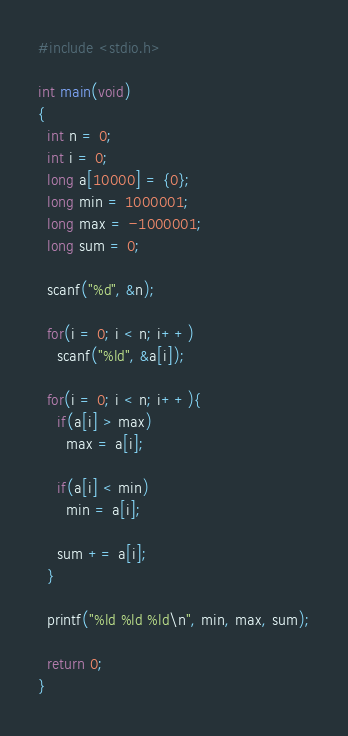Convert code to text. <code><loc_0><loc_0><loc_500><loc_500><_C_>#include <stdio.h>

int main(void)
{
  int n = 0;
  int i = 0;
  long a[10000] = {0};
  long min = 1000001;
  long max = -1000001;
  long sum = 0;

  scanf("%d", &n);

  for(i = 0; i < n; i++)
    scanf("%ld", &a[i]);

  for(i = 0; i < n; i++){
    if(a[i] > max)
      max = a[i];
    
    if(a[i] < min)
      min = a[i];

    sum += a[i];
  } 

  printf("%ld %ld %ld\n", min, max, sum);
  
  return 0;
}</code> 